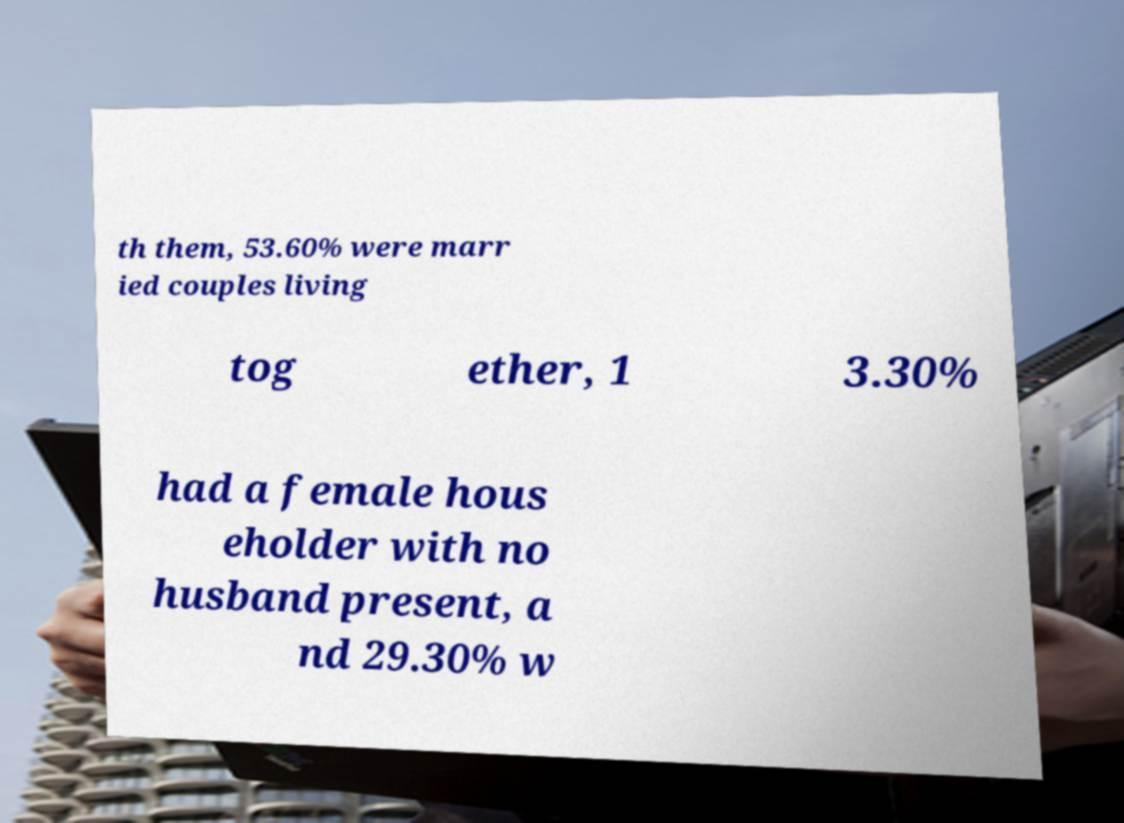For documentation purposes, I need the text within this image transcribed. Could you provide that? th them, 53.60% were marr ied couples living tog ether, 1 3.30% had a female hous eholder with no husband present, a nd 29.30% w 